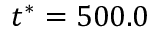Convert formula to latex. <formula><loc_0><loc_0><loc_500><loc_500>t ^ { * } = 5 0 0 . 0</formula> 